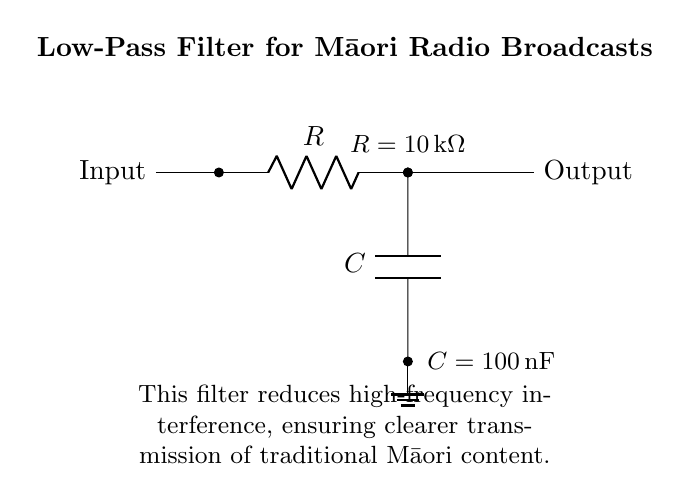What is the main purpose of this filter? The main purpose of the low-pass filter is to reduce high-frequency interference, which can degrade the quality of the transmission, particularly in traditional Māori radio broadcasts.
Answer: To reduce high-frequency interference What type of filter is depicted in this circuit? The circuit shows a low-pass filter which allows signals below a certain frequency to pass and attenuates signals above that frequency. This is characterized by its use of a resistor and capacitor.
Answer: Low-pass filter What is the value of the resistor used in this circuit? The resistor value is specifically labeled in the diagram, showing that it is ten kilohms.
Answer: Ten kilohms What is the value of the capacitor used in this design? The value of the capacitor is also labeled in the circuit as one hundred nanofarads, confirming the specifications for the filter.
Answer: One hundred nanofarads What does the output represent in this low-pass filter circuit? The output node represents the filtered signal that is free from high-frequency noise, ready for transmission in the radio broadcast.
Answer: Filtered signal What effect does increasing the resistor value have on the filter's cutoff frequency? Increasing the resistor value would decrease the cutoff frequency of the low-pass filter, allowing lower frequencies to pass through while reducing higher frequencies even more. This is calculated using the formula relating resistance, capacitance, and cutoff frequency.
Answer: Decrease cutoff frequency 